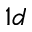Convert formula to latex. <formula><loc_0><loc_0><loc_500><loc_500>1 d</formula> 